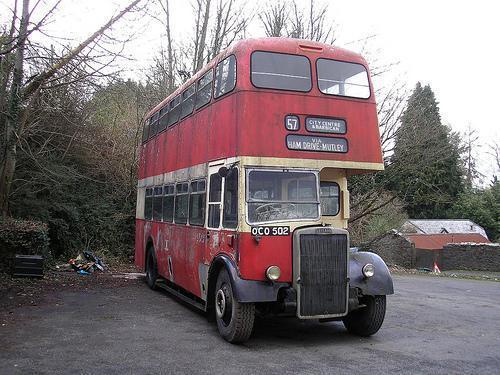How many buses are photographed?
Give a very brief answer. 1. 